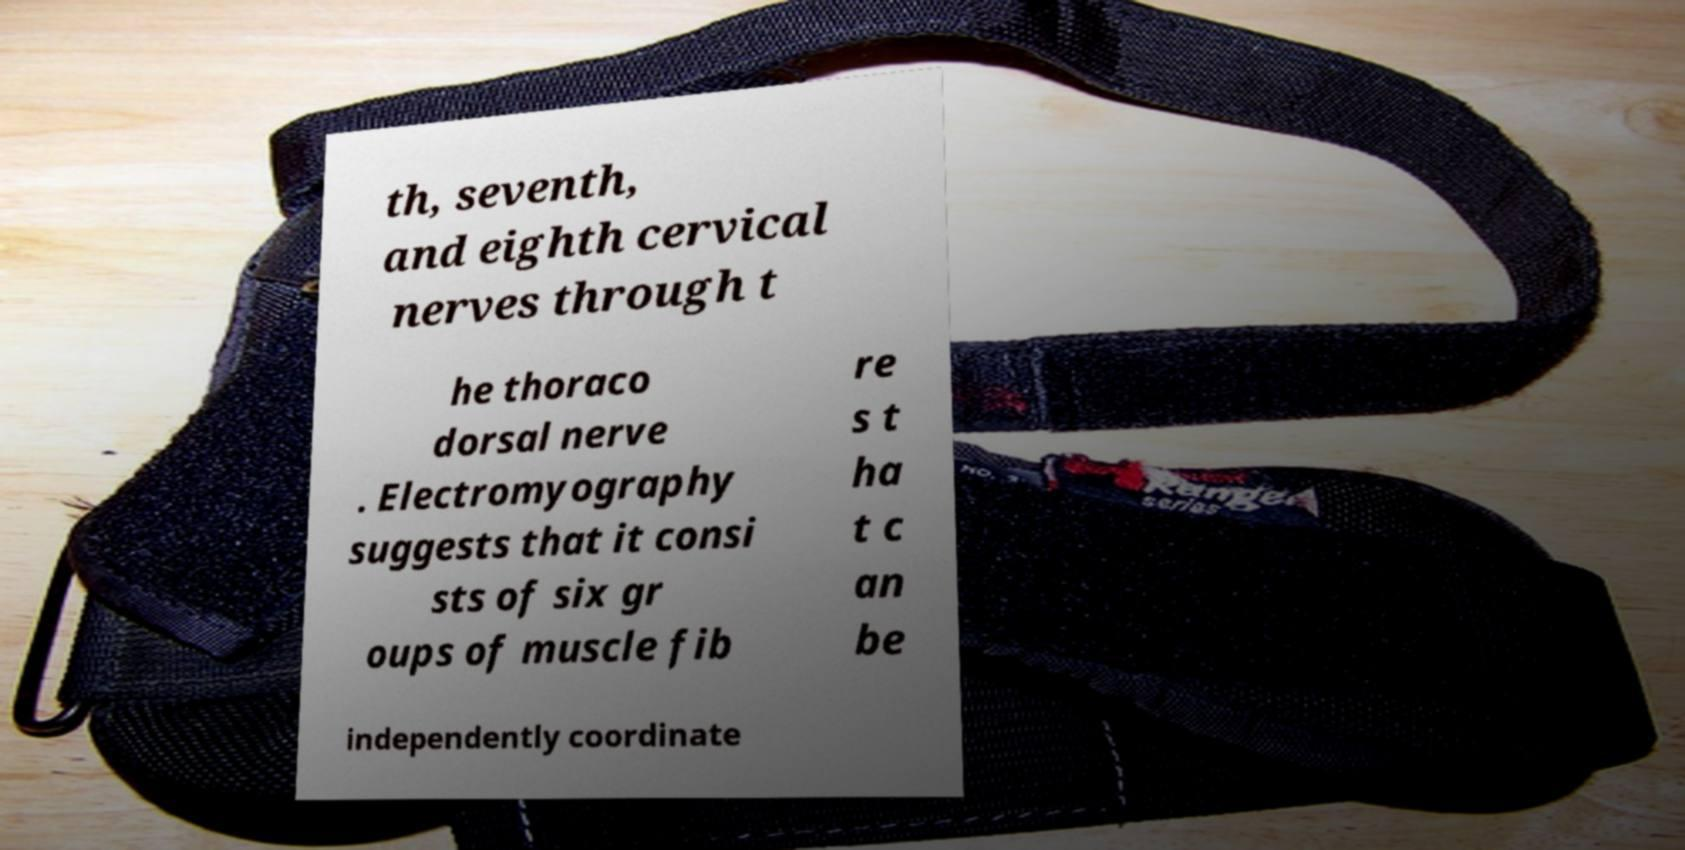Please identify and transcribe the text found in this image. th, seventh, and eighth cervical nerves through t he thoraco dorsal nerve . Electromyography suggests that it consi sts of six gr oups of muscle fib re s t ha t c an be independently coordinate 